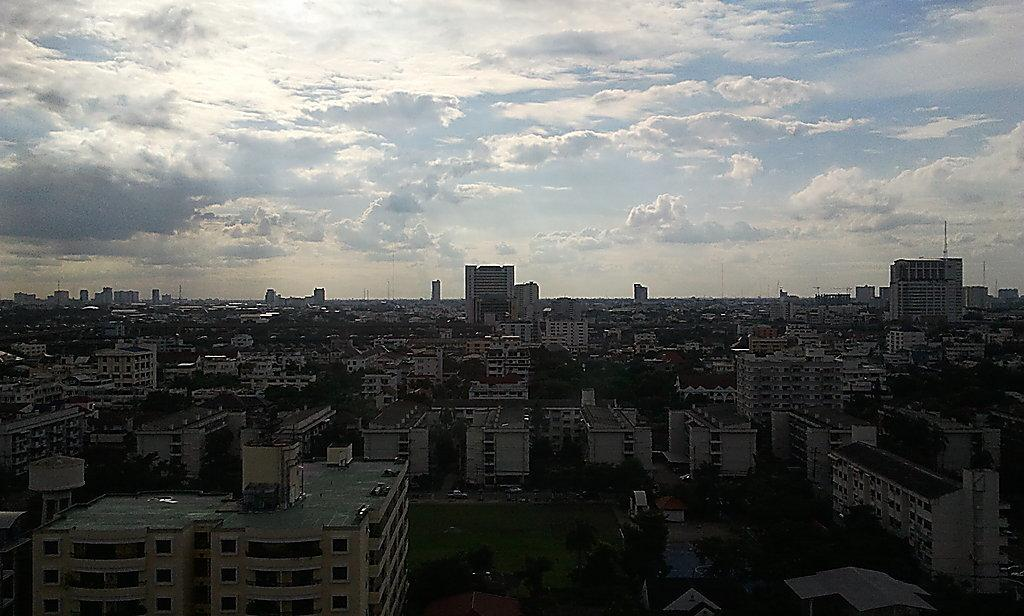What type of structures can be seen in the image? There are many buildings in the image. What architectural features can be observed on the buildings? Windows are visible in the image. What type of vegetation is present in the image? There are trees and grass visible in the image. What type of urban infrastructure is present in the image? There are poles in the image. What type of transportation is present in the image? There are vehicles on the road in the image. What is visible in the sky in the image? There are clouds in the sky in the image. Where is the harbor located in the image? There is no harbor present in the image. How does the faucet twist in the image? There is no faucet present in the image, so it cannot twist. 